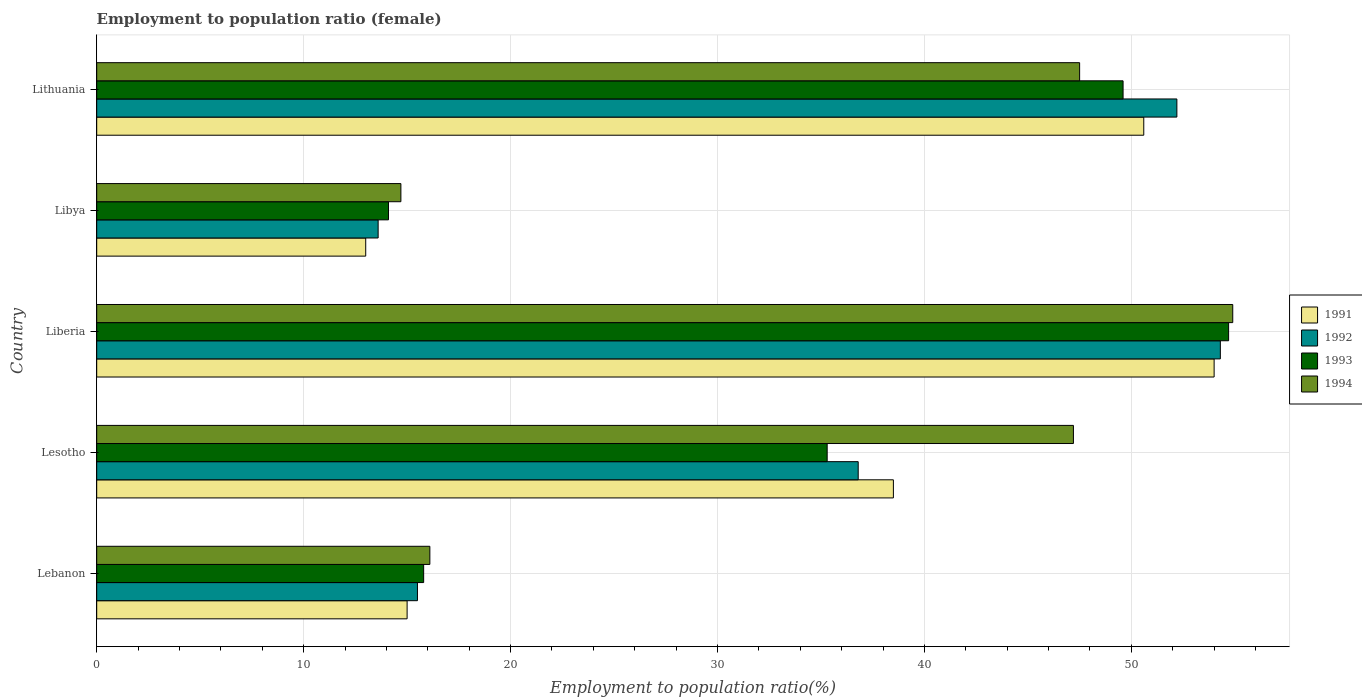How many different coloured bars are there?
Provide a short and direct response. 4. Are the number of bars per tick equal to the number of legend labels?
Provide a short and direct response. Yes. Are the number of bars on each tick of the Y-axis equal?
Make the answer very short. Yes. How many bars are there on the 4th tick from the top?
Your answer should be very brief. 4. How many bars are there on the 2nd tick from the bottom?
Offer a terse response. 4. What is the label of the 2nd group of bars from the top?
Offer a terse response. Libya. In how many cases, is the number of bars for a given country not equal to the number of legend labels?
Give a very brief answer. 0. What is the employment to population ratio in 1992 in Lithuania?
Offer a terse response. 52.2. Across all countries, what is the maximum employment to population ratio in 1993?
Provide a short and direct response. 54.7. Across all countries, what is the minimum employment to population ratio in 1991?
Offer a very short reply. 13. In which country was the employment to population ratio in 1991 maximum?
Offer a very short reply. Liberia. In which country was the employment to population ratio in 1993 minimum?
Offer a very short reply. Libya. What is the total employment to population ratio in 1991 in the graph?
Your answer should be compact. 171.1. What is the difference between the employment to population ratio in 1994 in Lesotho and that in Lithuania?
Keep it short and to the point. -0.3. What is the difference between the employment to population ratio in 1994 in Liberia and the employment to population ratio in 1993 in Lithuania?
Your answer should be compact. 5.3. What is the average employment to population ratio in 1993 per country?
Your response must be concise. 33.9. What is the difference between the employment to population ratio in 1994 and employment to population ratio in 1991 in Libya?
Make the answer very short. 1.7. What is the ratio of the employment to population ratio in 1992 in Liberia to that in Libya?
Keep it short and to the point. 3.99. What is the difference between the highest and the second highest employment to population ratio in 1991?
Your response must be concise. 3.4. What is the difference between the highest and the lowest employment to population ratio in 1992?
Make the answer very short. 40.7. In how many countries, is the employment to population ratio in 1991 greater than the average employment to population ratio in 1991 taken over all countries?
Offer a very short reply. 3. Is the sum of the employment to population ratio in 1994 in Lebanon and Libya greater than the maximum employment to population ratio in 1991 across all countries?
Provide a succinct answer. No. Is it the case that in every country, the sum of the employment to population ratio in 1991 and employment to population ratio in 1993 is greater than the sum of employment to population ratio in 1994 and employment to population ratio in 1992?
Make the answer very short. No. How many bars are there?
Your answer should be compact. 20. Are all the bars in the graph horizontal?
Your answer should be compact. Yes. How many countries are there in the graph?
Give a very brief answer. 5. Does the graph contain any zero values?
Provide a succinct answer. No. Does the graph contain grids?
Your answer should be compact. Yes. Where does the legend appear in the graph?
Your answer should be compact. Center right. How many legend labels are there?
Offer a terse response. 4. What is the title of the graph?
Your answer should be very brief. Employment to population ratio (female). What is the label or title of the X-axis?
Offer a terse response. Employment to population ratio(%). What is the Employment to population ratio(%) of 1993 in Lebanon?
Give a very brief answer. 15.8. What is the Employment to population ratio(%) in 1994 in Lebanon?
Ensure brevity in your answer.  16.1. What is the Employment to population ratio(%) in 1991 in Lesotho?
Your answer should be very brief. 38.5. What is the Employment to population ratio(%) of 1992 in Lesotho?
Provide a succinct answer. 36.8. What is the Employment to population ratio(%) in 1993 in Lesotho?
Your answer should be very brief. 35.3. What is the Employment to population ratio(%) in 1994 in Lesotho?
Keep it short and to the point. 47.2. What is the Employment to population ratio(%) in 1991 in Liberia?
Give a very brief answer. 54. What is the Employment to population ratio(%) in 1992 in Liberia?
Offer a terse response. 54.3. What is the Employment to population ratio(%) in 1993 in Liberia?
Your answer should be very brief. 54.7. What is the Employment to population ratio(%) of 1994 in Liberia?
Provide a short and direct response. 54.9. What is the Employment to population ratio(%) in 1991 in Libya?
Your response must be concise. 13. What is the Employment to population ratio(%) in 1992 in Libya?
Make the answer very short. 13.6. What is the Employment to population ratio(%) of 1993 in Libya?
Make the answer very short. 14.1. What is the Employment to population ratio(%) in 1994 in Libya?
Offer a very short reply. 14.7. What is the Employment to population ratio(%) of 1991 in Lithuania?
Your answer should be compact. 50.6. What is the Employment to population ratio(%) in 1992 in Lithuania?
Provide a succinct answer. 52.2. What is the Employment to population ratio(%) of 1993 in Lithuania?
Offer a terse response. 49.6. What is the Employment to population ratio(%) of 1994 in Lithuania?
Make the answer very short. 47.5. Across all countries, what is the maximum Employment to population ratio(%) of 1992?
Provide a succinct answer. 54.3. Across all countries, what is the maximum Employment to population ratio(%) in 1993?
Provide a short and direct response. 54.7. Across all countries, what is the maximum Employment to population ratio(%) in 1994?
Provide a short and direct response. 54.9. Across all countries, what is the minimum Employment to population ratio(%) in 1991?
Offer a terse response. 13. Across all countries, what is the minimum Employment to population ratio(%) in 1992?
Offer a terse response. 13.6. Across all countries, what is the minimum Employment to population ratio(%) of 1993?
Give a very brief answer. 14.1. Across all countries, what is the minimum Employment to population ratio(%) of 1994?
Your response must be concise. 14.7. What is the total Employment to population ratio(%) in 1991 in the graph?
Provide a short and direct response. 171.1. What is the total Employment to population ratio(%) in 1992 in the graph?
Make the answer very short. 172.4. What is the total Employment to population ratio(%) of 1993 in the graph?
Ensure brevity in your answer.  169.5. What is the total Employment to population ratio(%) of 1994 in the graph?
Ensure brevity in your answer.  180.4. What is the difference between the Employment to population ratio(%) in 1991 in Lebanon and that in Lesotho?
Your answer should be very brief. -23.5. What is the difference between the Employment to population ratio(%) of 1992 in Lebanon and that in Lesotho?
Provide a succinct answer. -21.3. What is the difference between the Employment to population ratio(%) of 1993 in Lebanon and that in Lesotho?
Your answer should be compact. -19.5. What is the difference between the Employment to population ratio(%) in 1994 in Lebanon and that in Lesotho?
Ensure brevity in your answer.  -31.1. What is the difference between the Employment to population ratio(%) of 1991 in Lebanon and that in Liberia?
Offer a terse response. -39. What is the difference between the Employment to population ratio(%) in 1992 in Lebanon and that in Liberia?
Your answer should be very brief. -38.8. What is the difference between the Employment to population ratio(%) of 1993 in Lebanon and that in Liberia?
Offer a very short reply. -38.9. What is the difference between the Employment to population ratio(%) in 1994 in Lebanon and that in Liberia?
Make the answer very short. -38.8. What is the difference between the Employment to population ratio(%) of 1991 in Lebanon and that in Libya?
Provide a short and direct response. 2. What is the difference between the Employment to population ratio(%) of 1992 in Lebanon and that in Libya?
Give a very brief answer. 1.9. What is the difference between the Employment to population ratio(%) of 1993 in Lebanon and that in Libya?
Keep it short and to the point. 1.7. What is the difference between the Employment to population ratio(%) of 1991 in Lebanon and that in Lithuania?
Ensure brevity in your answer.  -35.6. What is the difference between the Employment to population ratio(%) of 1992 in Lebanon and that in Lithuania?
Make the answer very short. -36.7. What is the difference between the Employment to population ratio(%) in 1993 in Lebanon and that in Lithuania?
Provide a short and direct response. -33.8. What is the difference between the Employment to population ratio(%) of 1994 in Lebanon and that in Lithuania?
Provide a short and direct response. -31.4. What is the difference between the Employment to population ratio(%) in 1991 in Lesotho and that in Liberia?
Make the answer very short. -15.5. What is the difference between the Employment to population ratio(%) of 1992 in Lesotho and that in Liberia?
Offer a very short reply. -17.5. What is the difference between the Employment to population ratio(%) in 1993 in Lesotho and that in Liberia?
Ensure brevity in your answer.  -19.4. What is the difference between the Employment to population ratio(%) of 1994 in Lesotho and that in Liberia?
Your response must be concise. -7.7. What is the difference between the Employment to population ratio(%) of 1992 in Lesotho and that in Libya?
Ensure brevity in your answer.  23.2. What is the difference between the Employment to population ratio(%) in 1993 in Lesotho and that in Libya?
Your answer should be compact. 21.2. What is the difference between the Employment to population ratio(%) in 1994 in Lesotho and that in Libya?
Keep it short and to the point. 32.5. What is the difference between the Employment to population ratio(%) of 1992 in Lesotho and that in Lithuania?
Make the answer very short. -15.4. What is the difference between the Employment to population ratio(%) of 1993 in Lesotho and that in Lithuania?
Offer a terse response. -14.3. What is the difference between the Employment to population ratio(%) of 1992 in Liberia and that in Libya?
Ensure brevity in your answer.  40.7. What is the difference between the Employment to population ratio(%) of 1993 in Liberia and that in Libya?
Your answer should be compact. 40.6. What is the difference between the Employment to population ratio(%) in 1994 in Liberia and that in Libya?
Give a very brief answer. 40.2. What is the difference between the Employment to population ratio(%) in 1991 in Liberia and that in Lithuania?
Keep it short and to the point. 3.4. What is the difference between the Employment to population ratio(%) of 1992 in Liberia and that in Lithuania?
Provide a short and direct response. 2.1. What is the difference between the Employment to population ratio(%) of 1993 in Liberia and that in Lithuania?
Provide a short and direct response. 5.1. What is the difference between the Employment to population ratio(%) of 1994 in Liberia and that in Lithuania?
Ensure brevity in your answer.  7.4. What is the difference between the Employment to population ratio(%) in 1991 in Libya and that in Lithuania?
Your answer should be compact. -37.6. What is the difference between the Employment to population ratio(%) in 1992 in Libya and that in Lithuania?
Give a very brief answer. -38.6. What is the difference between the Employment to population ratio(%) of 1993 in Libya and that in Lithuania?
Your answer should be compact. -35.5. What is the difference between the Employment to population ratio(%) of 1994 in Libya and that in Lithuania?
Your response must be concise. -32.8. What is the difference between the Employment to population ratio(%) of 1991 in Lebanon and the Employment to population ratio(%) of 1992 in Lesotho?
Your response must be concise. -21.8. What is the difference between the Employment to population ratio(%) in 1991 in Lebanon and the Employment to population ratio(%) in 1993 in Lesotho?
Your response must be concise. -20.3. What is the difference between the Employment to population ratio(%) in 1991 in Lebanon and the Employment to population ratio(%) in 1994 in Lesotho?
Offer a terse response. -32.2. What is the difference between the Employment to population ratio(%) of 1992 in Lebanon and the Employment to population ratio(%) of 1993 in Lesotho?
Provide a short and direct response. -19.8. What is the difference between the Employment to population ratio(%) of 1992 in Lebanon and the Employment to population ratio(%) of 1994 in Lesotho?
Provide a short and direct response. -31.7. What is the difference between the Employment to population ratio(%) in 1993 in Lebanon and the Employment to population ratio(%) in 1994 in Lesotho?
Make the answer very short. -31.4. What is the difference between the Employment to population ratio(%) of 1991 in Lebanon and the Employment to population ratio(%) of 1992 in Liberia?
Give a very brief answer. -39.3. What is the difference between the Employment to population ratio(%) in 1991 in Lebanon and the Employment to population ratio(%) in 1993 in Liberia?
Offer a very short reply. -39.7. What is the difference between the Employment to population ratio(%) in 1991 in Lebanon and the Employment to population ratio(%) in 1994 in Liberia?
Make the answer very short. -39.9. What is the difference between the Employment to population ratio(%) of 1992 in Lebanon and the Employment to population ratio(%) of 1993 in Liberia?
Offer a terse response. -39.2. What is the difference between the Employment to population ratio(%) of 1992 in Lebanon and the Employment to population ratio(%) of 1994 in Liberia?
Your response must be concise. -39.4. What is the difference between the Employment to population ratio(%) in 1993 in Lebanon and the Employment to population ratio(%) in 1994 in Liberia?
Offer a very short reply. -39.1. What is the difference between the Employment to population ratio(%) of 1991 in Lebanon and the Employment to population ratio(%) of 1994 in Libya?
Keep it short and to the point. 0.3. What is the difference between the Employment to population ratio(%) of 1992 in Lebanon and the Employment to population ratio(%) of 1994 in Libya?
Provide a short and direct response. 0.8. What is the difference between the Employment to population ratio(%) in 1991 in Lebanon and the Employment to population ratio(%) in 1992 in Lithuania?
Your answer should be compact. -37.2. What is the difference between the Employment to population ratio(%) in 1991 in Lebanon and the Employment to population ratio(%) in 1993 in Lithuania?
Offer a very short reply. -34.6. What is the difference between the Employment to population ratio(%) of 1991 in Lebanon and the Employment to population ratio(%) of 1994 in Lithuania?
Make the answer very short. -32.5. What is the difference between the Employment to population ratio(%) in 1992 in Lebanon and the Employment to population ratio(%) in 1993 in Lithuania?
Keep it short and to the point. -34.1. What is the difference between the Employment to population ratio(%) of 1992 in Lebanon and the Employment to population ratio(%) of 1994 in Lithuania?
Offer a terse response. -32. What is the difference between the Employment to population ratio(%) of 1993 in Lebanon and the Employment to population ratio(%) of 1994 in Lithuania?
Give a very brief answer. -31.7. What is the difference between the Employment to population ratio(%) of 1991 in Lesotho and the Employment to population ratio(%) of 1992 in Liberia?
Provide a short and direct response. -15.8. What is the difference between the Employment to population ratio(%) in 1991 in Lesotho and the Employment to population ratio(%) in 1993 in Liberia?
Your response must be concise. -16.2. What is the difference between the Employment to population ratio(%) of 1991 in Lesotho and the Employment to population ratio(%) of 1994 in Liberia?
Keep it short and to the point. -16.4. What is the difference between the Employment to population ratio(%) in 1992 in Lesotho and the Employment to population ratio(%) in 1993 in Liberia?
Keep it short and to the point. -17.9. What is the difference between the Employment to population ratio(%) of 1992 in Lesotho and the Employment to population ratio(%) of 1994 in Liberia?
Your answer should be very brief. -18.1. What is the difference between the Employment to population ratio(%) in 1993 in Lesotho and the Employment to population ratio(%) in 1994 in Liberia?
Make the answer very short. -19.6. What is the difference between the Employment to population ratio(%) of 1991 in Lesotho and the Employment to population ratio(%) of 1992 in Libya?
Ensure brevity in your answer.  24.9. What is the difference between the Employment to population ratio(%) of 1991 in Lesotho and the Employment to population ratio(%) of 1993 in Libya?
Your answer should be compact. 24.4. What is the difference between the Employment to population ratio(%) in 1991 in Lesotho and the Employment to population ratio(%) in 1994 in Libya?
Provide a short and direct response. 23.8. What is the difference between the Employment to population ratio(%) of 1992 in Lesotho and the Employment to population ratio(%) of 1993 in Libya?
Give a very brief answer. 22.7. What is the difference between the Employment to population ratio(%) of 1992 in Lesotho and the Employment to population ratio(%) of 1994 in Libya?
Provide a short and direct response. 22.1. What is the difference between the Employment to population ratio(%) of 1993 in Lesotho and the Employment to population ratio(%) of 1994 in Libya?
Your answer should be compact. 20.6. What is the difference between the Employment to population ratio(%) in 1991 in Lesotho and the Employment to population ratio(%) in 1992 in Lithuania?
Your answer should be compact. -13.7. What is the difference between the Employment to population ratio(%) of 1991 in Lesotho and the Employment to population ratio(%) of 1993 in Lithuania?
Provide a succinct answer. -11.1. What is the difference between the Employment to population ratio(%) in 1993 in Lesotho and the Employment to population ratio(%) in 1994 in Lithuania?
Your answer should be very brief. -12.2. What is the difference between the Employment to population ratio(%) of 1991 in Liberia and the Employment to population ratio(%) of 1992 in Libya?
Your response must be concise. 40.4. What is the difference between the Employment to population ratio(%) of 1991 in Liberia and the Employment to population ratio(%) of 1993 in Libya?
Your response must be concise. 39.9. What is the difference between the Employment to population ratio(%) of 1991 in Liberia and the Employment to population ratio(%) of 1994 in Libya?
Offer a very short reply. 39.3. What is the difference between the Employment to population ratio(%) of 1992 in Liberia and the Employment to population ratio(%) of 1993 in Libya?
Give a very brief answer. 40.2. What is the difference between the Employment to population ratio(%) of 1992 in Liberia and the Employment to population ratio(%) of 1994 in Libya?
Offer a very short reply. 39.6. What is the difference between the Employment to population ratio(%) of 1991 in Liberia and the Employment to population ratio(%) of 1993 in Lithuania?
Your response must be concise. 4.4. What is the difference between the Employment to population ratio(%) in 1991 in Liberia and the Employment to population ratio(%) in 1994 in Lithuania?
Your answer should be very brief. 6.5. What is the difference between the Employment to population ratio(%) in 1993 in Liberia and the Employment to population ratio(%) in 1994 in Lithuania?
Offer a terse response. 7.2. What is the difference between the Employment to population ratio(%) of 1991 in Libya and the Employment to population ratio(%) of 1992 in Lithuania?
Keep it short and to the point. -39.2. What is the difference between the Employment to population ratio(%) in 1991 in Libya and the Employment to population ratio(%) in 1993 in Lithuania?
Offer a very short reply. -36.6. What is the difference between the Employment to population ratio(%) of 1991 in Libya and the Employment to population ratio(%) of 1994 in Lithuania?
Make the answer very short. -34.5. What is the difference between the Employment to population ratio(%) in 1992 in Libya and the Employment to population ratio(%) in 1993 in Lithuania?
Offer a terse response. -36. What is the difference between the Employment to population ratio(%) in 1992 in Libya and the Employment to population ratio(%) in 1994 in Lithuania?
Offer a terse response. -33.9. What is the difference between the Employment to population ratio(%) in 1993 in Libya and the Employment to population ratio(%) in 1994 in Lithuania?
Make the answer very short. -33.4. What is the average Employment to population ratio(%) in 1991 per country?
Make the answer very short. 34.22. What is the average Employment to population ratio(%) in 1992 per country?
Make the answer very short. 34.48. What is the average Employment to population ratio(%) of 1993 per country?
Your answer should be very brief. 33.9. What is the average Employment to population ratio(%) in 1994 per country?
Make the answer very short. 36.08. What is the difference between the Employment to population ratio(%) in 1991 and Employment to population ratio(%) in 1993 in Lebanon?
Make the answer very short. -0.8. What is the difference between the Employment to population ratio(%) of 1991 and Employment to population ratio(%) of 1994 in Lebanon?
Ensure brevity in your answer.  -1.1. What is the difference between the Employment to population ratio(%) of 1992 and Employment to population ratio(%) of 1994 in Lebanon?
Keep it short and to the point. -0.6. What is the difference between the Employment to population ratio(%) of 1991 and Employment to population ratio(%) of 1993 in Lesotho?
Keep it short and to the point. 3.2. What is the difference between the Employment to population ratio(%) in 1992 and Employment to population ratio(%) in 1994 in Lesotho?
Provide a succinct answer. -10.4. What is the difference between the Employment to population ratio(%) of 1993 and Employment to population ratio(%) of 1994 in Lesotho?
Offer a very short reply. -11.9. What is the difference between the Employment to population ratio(%) in 1991 and Employment to population ratio(%) in 1993 in Liberia?
Ensure brevity in your answer.  -0.7. What is the difference between the Employment to population ratio(%) in 1991 and Employment to population ratio(%) in 1994 in Liberia?
Ensure brevity in your answer.  -0.9. What is the difference between the Employment to population ratio(%) of 1993 and Employment to population ratio(%) of 1994 in Liberia?
Make the answer very short. -0.2. What is the difference between the Employment to population ratio(%) of 1991 and Employment to population ratio(%) of 1992 in Libya?
Provide a short and direct response. -0.6. What is the difference between the Employment to population ratio(%) in 1992 and Employment to population ratio(%) in 1993 in Libya?
Your response must be concise. -0.5. What is the difference between the Employment to population ratio(%) in 1992 and Employment to population ratio(%) in 1994 in Libya?
Your answer should be compact. -1.1. What is the difference between the Employment to population ratio(%) of 1993 and Employment to population ratio(%) of 1994 in Libya?
Ensure brevity in your answer.  -0.6. What is the difference between the Employment to population ratio(%) of 1991 and Employment to population ratio(%) of 1992 in Lithuania?
Offer a very short reply. -1.6. What is the difference between the Employment to population ratio(%) of 1993 and Employment to population ratio(%) of 1994 in Lithuania?
Offer a terse response. 2.1. What is the ratio of the Employment to population ratio(%) in 1991 in Lebanon to that in Lesotho?
Offer a terse response. 0.39. What is the ratio of the Employment to population ratio(%) in 1992 in Lebanon to that in Lesotho?
Ensure brevity in your answer.  0.42. What is the ratio of the Employment to population ratio(%) of 1993 in Lebanon to that in Lesotho?
Your answer should be very brief. 0.45. What is the ratio of the Employment to population ratio(%) of 1994 in Lebanon to that in Lesotho?
Offer a terse response. 0.34. What is the ratio of the Employment to population ratio(%) in 1991 in Lebanon to that in Liberia?
Keep it short and to the point. 0.28. What is the ratio of the Employment to population ratio(%) in 1992 in Lebanon to that in Liberia?
Provide a succinct answer. 0.29. What is the ratio of the Employment to population ratio(%) of 1993 in Lebanon to that in Liberia?
Give a very brief answer. 0.29. What is the ratio of the Employment to population ratio(%) of 1994 in Lebanon to that in Liberia?
Offer a very short reply. 0.29. What is the ratio of the Employment to population ratio(%) of 1991 in Lebanon to that in Libya?
Provide a short and direct response. 1.15. What is the ratio of the Employment to population ratio(%) in 1992 in Lebanon to that in Libya?
Make the answer very short. 1.14. What is the ratio of the Employment to population ratio(%) of 1993 in Lebanon to that in Libya?
Provide a short and direct response. 1.12. What is the ratio of the Employment to population ratio(%) in 1994 in Lebanon to that in Libya?
Your answer should be very brief. 1.1. What is the ratio of the Employment to population ratio(%) in 1991 in Lebanon to that in Lithuania?
Give a very brief answer. 0.3. What is the ratio of the Employment to population ratio(%) of 1992 in Lebanon to that in Lithuania?
Your answer should be compact. 0.3. What is the ratio of the Employment to population ratio(%) in 1993 in Lebanon to that in Lithuania?
Your response must be concise. 0.32. What is the ratio of the Employment to population ratio(%) in 1994 in Lebanon to that in Lithuania?
Your answer should be very brief. 0.34. What is the ratio of the Employment to population ratio(%) of 1991 in Lesotho to that in Liberia?
Ensure brevity in your answer.  0.71. What is the ratio of the Employment to population ratio(%) in 1992 in Lesotho to that in Liberia?
Make the answer very short. 0.68. What is the ratio of the Employment to population ratio(%) in 1993 in Lesotho to that in Liberia?
Offer a terse response. 0.65. What is the ratio of the Employment to population ratio(%) of 1994 in Lesotho to that in Liberia?
Your answer should be compact. 0.86. What is the ratio of the Employment to population ratio(%) of 1991 in Lesotho to that in Libya?
Provide a succinct answer. 2.96. What is the ratio of the Employment to population ratio(%) of 1992 in Lesotho to that in Libya?
Your answer should be very brief. 2.71. What is the ratio of the Employment to population ratio(%) in 1993 in Lesotho to that in Libya?
Your answer should be compact. 2.5. What is the ratio of the Employment to population ratio(%) of 1994 in Lesotho to that in Libya?
Your response must be concise. 3.21. What is the ratio of the Employment to population ratio(%) in 1991 in Lesotho to that in Lithuania?
Ensure brevity in your answer.  0.76. What is the ratio of the Employment to population ratio(%) of 1992 in Lesotho to that in Lithuania?
Offer a terse response. 0.7. What is the ratio of the Employment to population ratio(%) in 1993 in Lesotho to that in Lithuania?
Your response must be concise. 0.71. What is the ratio of the Employment to population ratio(%) in 1991 in Liberia to that in Libya?
Provide a short and direct response. 4.15. What is the ratio of the Employment to population ratio(%) of 1992 in Liberia to that in Libya?
Give a very brief answer. 3.99. What is the ratio of the Employment to population ratio(%) in 1993 in Liberia to that in Libya?
Your answer should be very brief. 3.88. What is the ratio of the Employment to population ratio(%) of 1994 in Liberia to that in Libya?
Provide a succinct answer. 3.73. What is the ratio of the Employment to population ratio(%) in 1991 in Liberia to that in Lithuania?
Your answer should be very brief. 1.07. What is the ratio of the Employment to population ratio(%) in 1992 in Liberia to that in Lithuania?
Your answer should be very brief. 1.04. What is the ratio of the Employment to population ratio(%) of 1993 in Liberia to that in Lithuania?
Offer a terse response. 1.1. What is the ratio of the Employment to population ratio(%) in 1994 in Liberia to that in Lithuania?
Your answer should be compact. 1.16. What is the ratio of the Employment to population ratio(%) of 1991 in Libya to that in Lithuania?
Offer a terse response. 0.26. What is the ratio of the Employment to population ratio(%) in 1992 in Libya to that in Lithuania?
Provide a succinct answer. 0.26. What is the ratio of the Employment to population ratio(%) in 1993 in Libya to that in Lithuania?
Keep it short and to the point. 0.28. What is the ratio of the Employment to population ratio(%) in 1994 in Libya to that in Lithuania?
Your response must be concise. 0.31. What is the difference between the highest and the second highest Employment to population ratio(%) of 1992?
Provide a succinct answer. 2.1. What is the difference between the highest and the lowest Employment to population ratio(%) in 1991?
Provide a short and direct response. 41. What is the difference between the highest and the lowest Employment to population ratio(%) of 1992?
Give a very brief answer. 40.7. What is the difference between the highest and the lowest Employment to population ratio(%) in 1993?
Your answer should be very brief. 40.6. What is the difference between the highest and the lowest Employment to population ratio(%) of 1994?
Your answer should be compact. 40.2. 